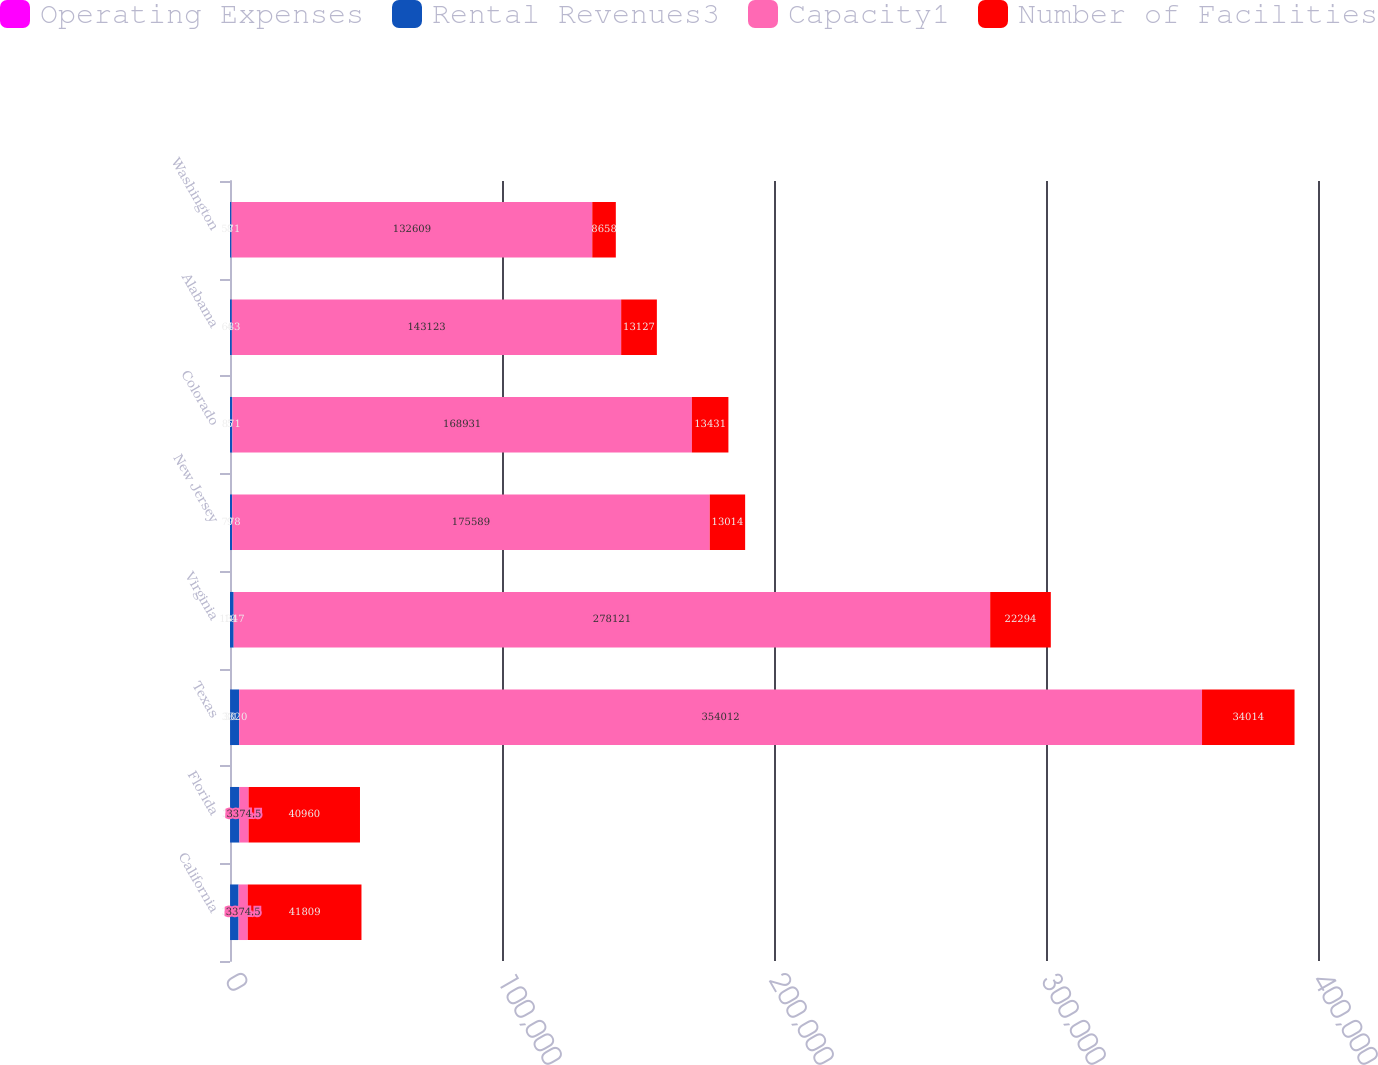<chart> <loc_0><loc_0><loc_500><loc_500><stacked_bar_chart><ecel><fcel>California<fcel>Florida<fcel>Texas<fcel>Virginia<fcel>New Jersey<fcel>Colorado<fcel>Alabama<fcel>Washington<nl><fcel>Operating Expenses<fcel>27<fcel>27<fcel>30<fcel>10<fcel>9<fcel>5<fcel>4<fcel>8<nl><fcel>Rental Revenues3<fcel>3124<fcel>3429<fcel>3320<fcel>1347<fcel>778<fcel>871<fcel>683<fcel>571<nl><fcel>Capacity1<fcel>3374.5<fcel>3374.5<fcel>354012<fcel>278121<fcel>175589<fcel>168931<fcel>143123<fcel>132609<nl><fcel>Number of Facilities<fcel>41809<fcel>40960<fcel>34014<fcel>22294<fcel>13014<fcel>13431<fcel>13127<fcel>8658<nl></chart> 